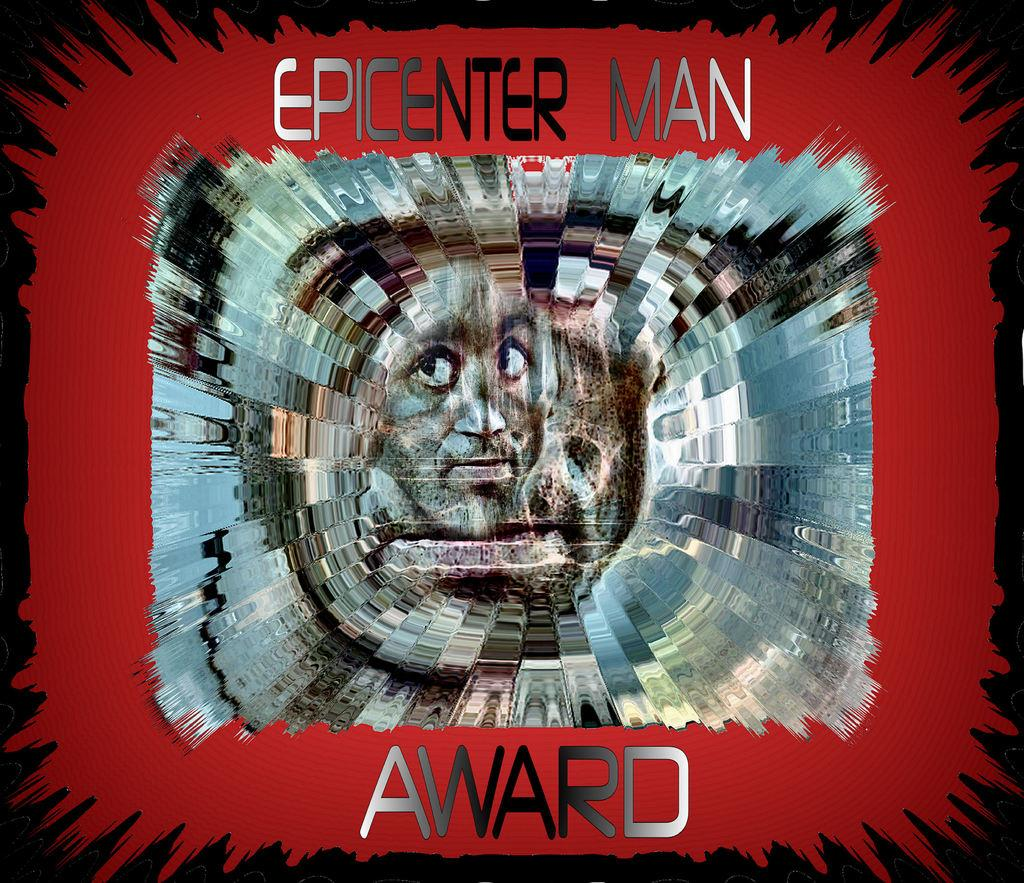What is the main subject of the image? The main subject of the image is a person's face. Are there any words or letters in the image? Yes, there is text in the image. What can be observed about the background of the image? The background of the image is dark. How many clouds are present in the image? There are no clouds visible in the image; the background is dark. What type of group is depicted in the image? There is no group present in the image; it features a person's face and text. 